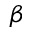Convert formula to latex. <formula><loc_0><loc_0><loc_500><loc_500>\beta</formula> 